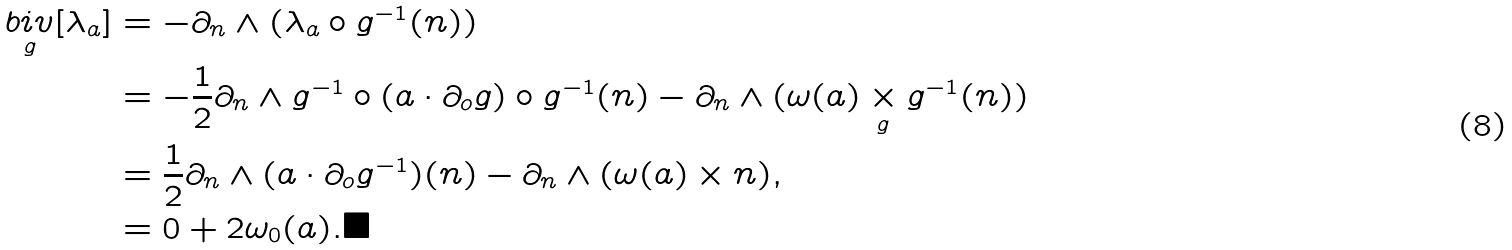Convert formula to latex. <formula><loc_0><loc_0><loc_500><loc_500>\underset { g } { b i v } [ \lambda _ { a } ] & = - \partial _ { n } \wedge ( \lambda _ { a } \circ g ^ { - 1 } ( n ) ) \\ & = - \frac { 1 } { 2 } \partial _ { n } \wedge g ^ { - 1 } \circ ( a \cdot \partial _ { o } g ) \circ g ^ { - 1 } ( n ) - \partial _ { n } \wedge ( \omega ( a ) \underset { g } { \times } g ^ { - 1 } ( n ) ) \\ & = \frac { 1 } { 2 } \partial _ { n } \wedge ( a \cdot \partial _ { o } g ^ { - 1 } ) ( n ) - \partial _ { n } \wedge ( \omega ( a ) \times n ) , \\ & = 0 + 2 \omega _ { 0 } ( a ) . \blacksquare</formula> 